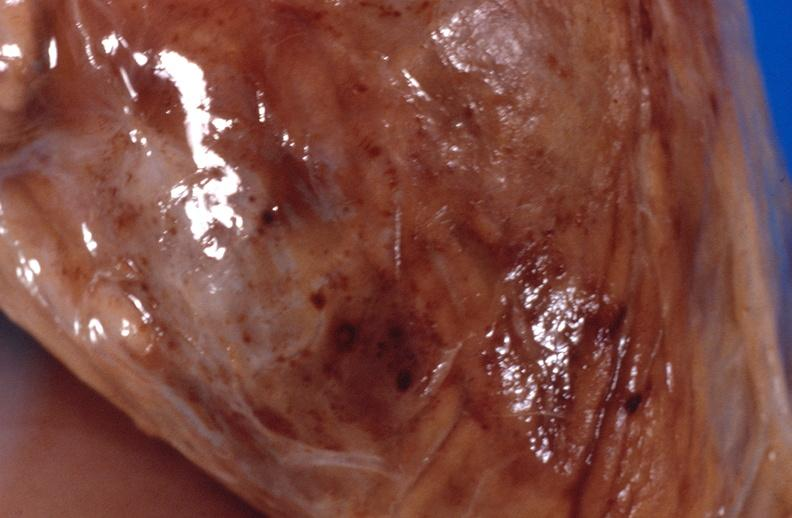what is present?
Answer the question using a single word or phrase. Soft tissue 